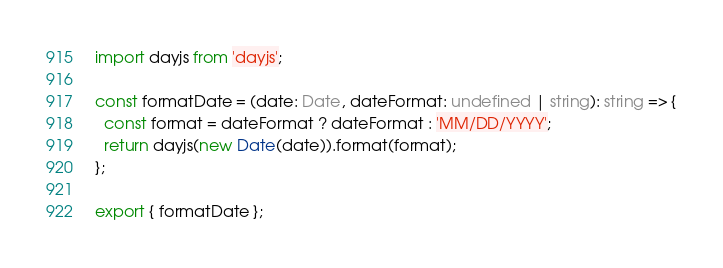<code> <loc_0><loc_0><loc_500><loc_500><_TypeScript_>import dayjs from 'dayjs';

const formatDate = (date: Date, dateFormat: undefined | string): string => {
  const format = dateFormat ? dateFormat : 'MM/DD/YYYY';
  return dayjs(new Date(date)).format(format);
};

export { formatDate };
</code> 